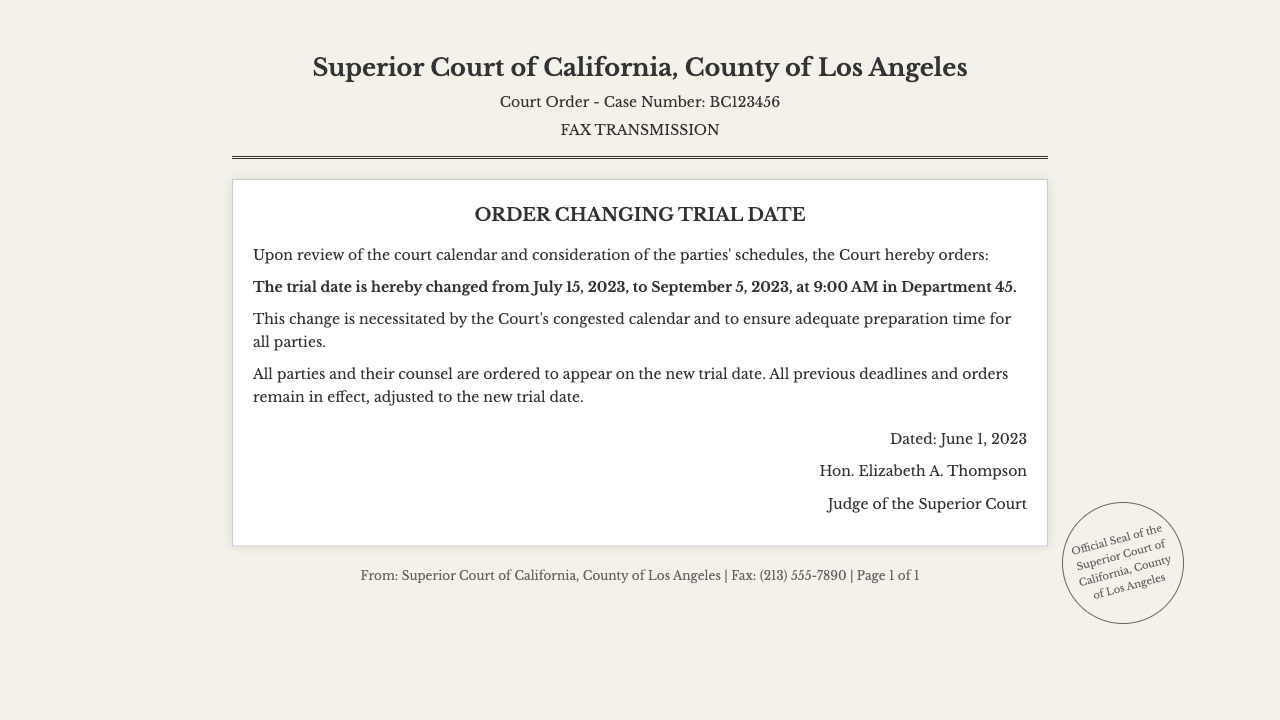What is the case number? The case number is explicitly mentioned in the document under the title as "Case Number: BC123456."
Answer: BC123456 What is the original trial date? The original trial date is listed in the court order as July 15, 2023.
Answer: July 15, 2023 What is the new trial date? The new trial date is provided in bold text as September 5, 2023.
Answer: September 5, 2023 Who is the judge? The judge's name is presented at the bottom of the court order as "Hon. Elizabeth A. Thompson."
Answer: Hon. Elizabeth A. Thompson What time is the trial scheduled? The scheduled time for the trial is indicated in the order as 9:00 AM.
Answer: 9:00 AM Why was the trial date changed? The reason for the change is described in the document as "the Court's congested calendar and to ensure adequate preparation time."
Answer: congested calendar and to ensure adequate preparation time How many pages does the fax contain? The document footer indicates "Page 1 of 1," suggesting there is only one page.
Answer: 1 What department is the trial set in? The department where the trial is set is noted as Department 45 in the order.
Answer: Department 45 